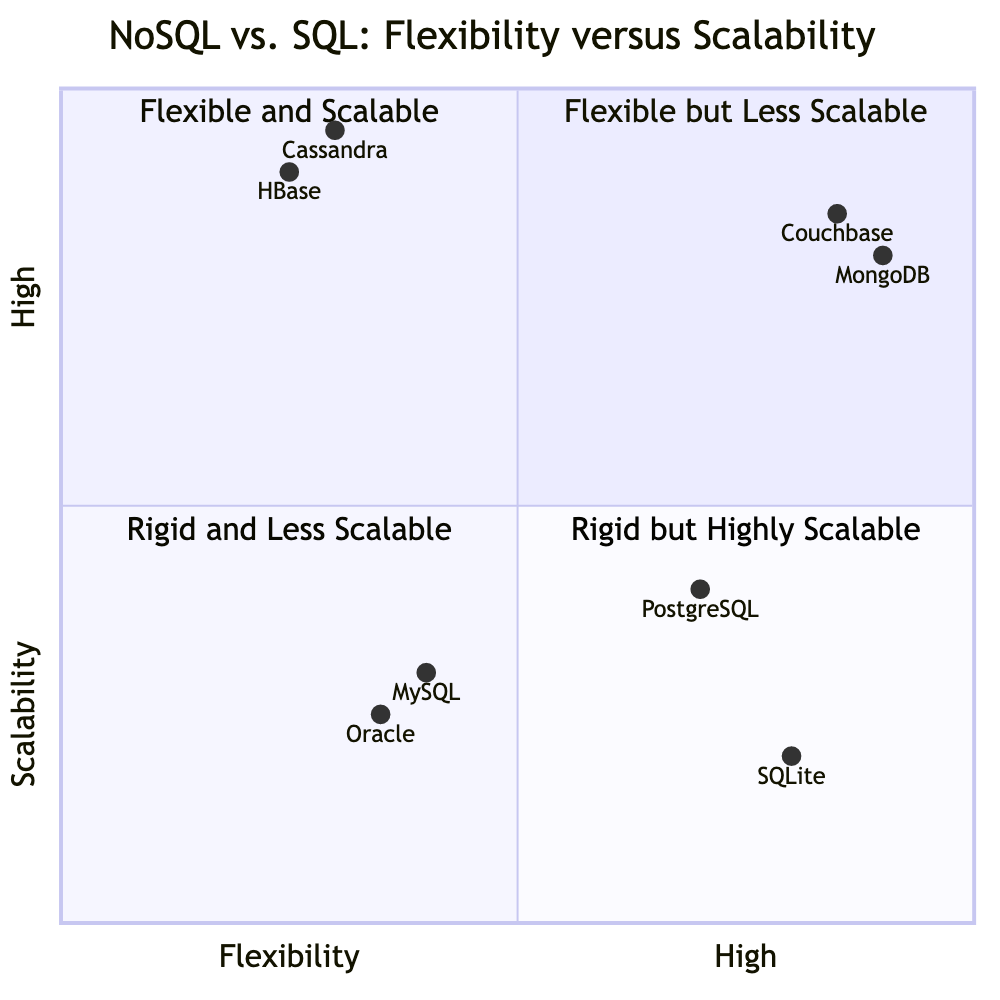What is the description of the quadrant labeled "Flexible and Scalable"? The quadrant labeled "Flexible and Scalable" describes systems that offer high flexibility and perform well with horizontal scaling.
Answer: Systems that offer high flexibility and perform well with horizontal scaling How many databases are in the quadrant "Rigid but Highly Scalable"? The quadrant "Rigid but Highly Scalable" contains two databases: Cassandra and HBase.
Answer: 2 Which database is located in the "Flexible but Less Scalable" quadrant and has a score of 0.7 on flexibility? PostgreSQL is located in the "Flexible but Less Scalable" quadrant and has a flexibility score of 0.7.
Answer: PostgreSQL What feature does Couchbase offer that relates to data modeling? Couchbase offers flexible data models, which means it can adapt to various data structures without strict schemas.
Answer: Flexible data models Which quadrant contains databases that have a combination of limited flexibility and high scalability? The quadrant labeled "Rigid but Highly Scalable" contains databases with limited flexibility but excel in high scalability.
Answer: Rigid but Highly Scalable What is the highest scalability score among the databases related to NoSQL in the diagram? MongoDB has the highest scalability score of 0.8 among the NoSQL databases represented in the chart.
Answer: 0.8 Which database has the lowest flexibility score, according to the diagram? According to the diagram, HBase has the lowest flexibility score of 0.25.
Answer: HBase What type of database is Cassandra classified as? Cassandra is classified as a wide-column store, which means it organizes data in a way that allows for efficient storage and retrieval across a distributed system.
Answer: Wide-column store Which quadrant contains MySQL and Oracle? MySQL and Oracle are both located in the quadrant labeled "Rigid and Less Scalable".
Answer: Rigid and Less Scalable How many databases are classified as "Flexible and Scalable"? There are two databases classified as "Flexible and Scalable": MongoDB and Couchbase.
Answer: 2 